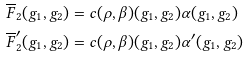Convert formula to latex. <formula><loc_0><loc_0><loc_500><loc_500>\overline { F } _ { 2 } ( g _ { 1 } , g _ { 2 } ) & = c ( \rho , \beta ) ( g _ { 1 } , g _ { 2 } ) \alpha ( g _ { 1 } , g _ { 2 } ) \\ \overline { F } ^ { \prime } _ { 2 } ( g _ { 1 } , g _ { 2 } ) & = c ( \rho , \beta ) ( g _ { 1 } , g _ { 2 } ) \alpha ^ { \prime } ( g _ { 1 } , g _ { 2 } )</formula> 